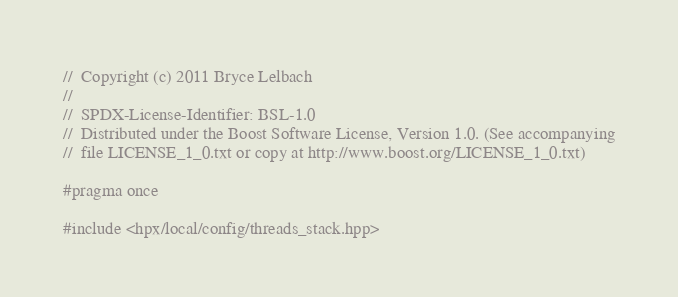<code> <loc_0><loc_0><loc_500><loc_500><_C++_>//  Copyright (c) 2011 Bryce Lelbach
//
//  SPDX-License-Identifier: BSL-1.0
//  Distributed under the Boost Software License, Version 1.0. (See accompanying
//  file LICENSE_1_0.txt or copy at http://www.boost.org/LICENSE_1_0.txt)

#pragma once

#include <hpx/local/config/threads_stack.hpp>
</code> 